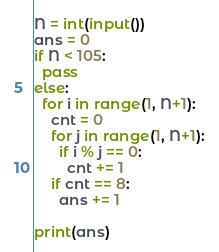<code> <loc_0><loc_0><loc_500><loc_500><_Python_>N = int(input())
ans = 0
if N < 105:
  pass
else:
  for i in range(1, N+1):
    cnt = 0
    for j in range(1, N+1):
      if i % j == 0:
        cnt += 1
    if cnt == 8:
      ans += 1
      
print(ans)  

</code> 